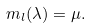<formula> <loc_0><loc_0><loc_500><loc_500>m _ { l } ( { \lambda } ) = { \mu . }</formula> 